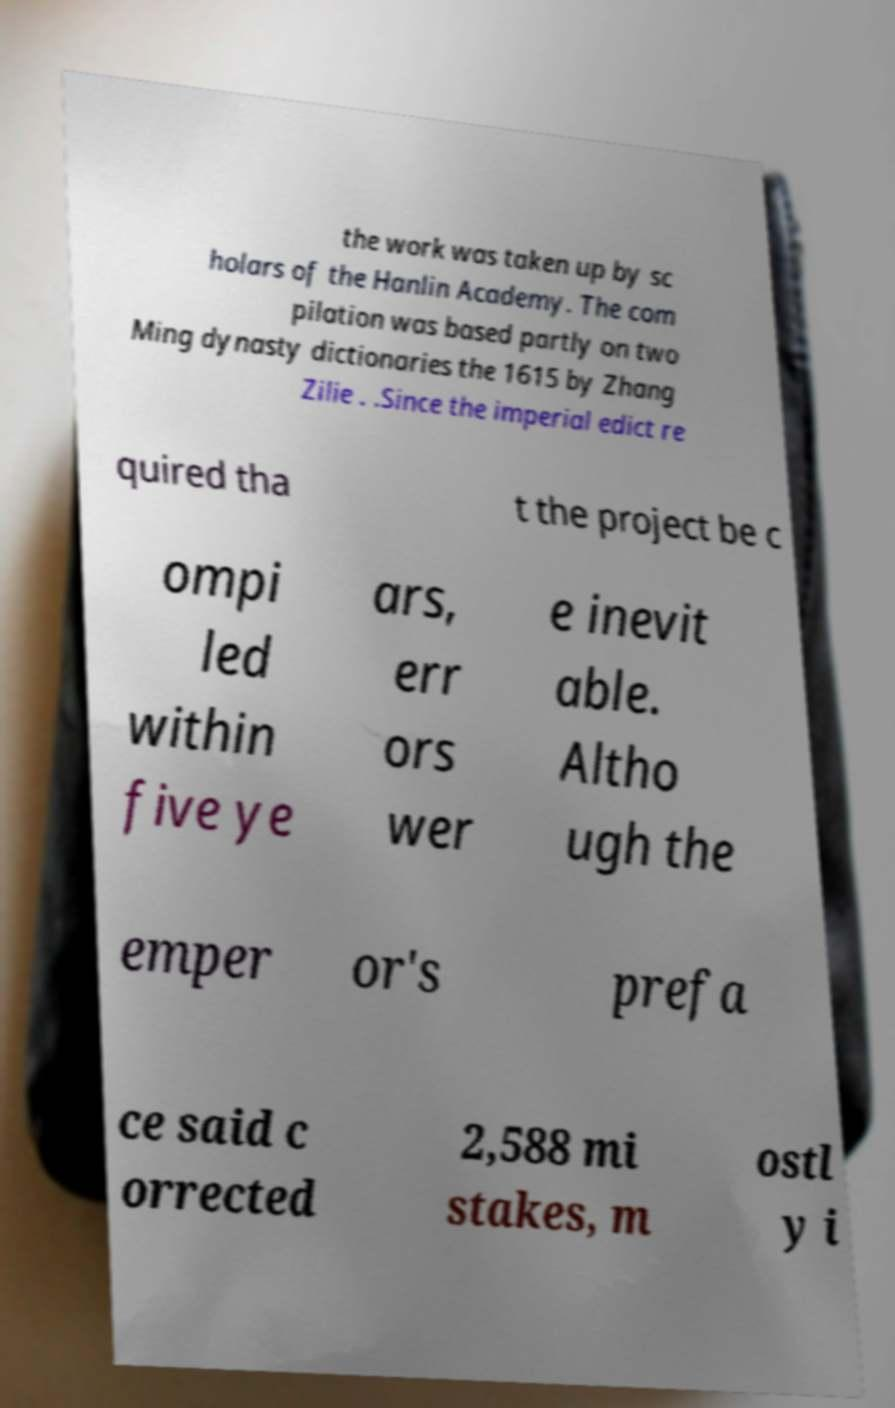Could you assist in decoding the text presented in this image and type it out clearly? the work was taken up by sc holars of the Hanlin Academy. The com pilation was based partly on two Ming dynasty dictionaries the 1615 by Zhang Zilie . .Since the imperial edict re quired tha t the project be c ompi led within five ye ars, err ors wer e inevit able. Altho ugh the emper or's prefa ce said c orrected 2,588 mi stakes, m ostl y i 